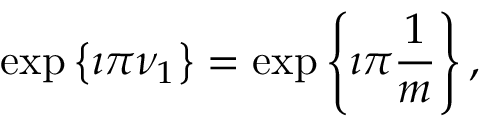Convert formula to latex. <formula><loc_0><loc_0><loc_500><loc_500>\exp \left \{ \imath \pi \nu _ { 1 } \right \} = \exp \left \{ \imath \pi \frac { 1 } { m } \right \} ,</formula> 